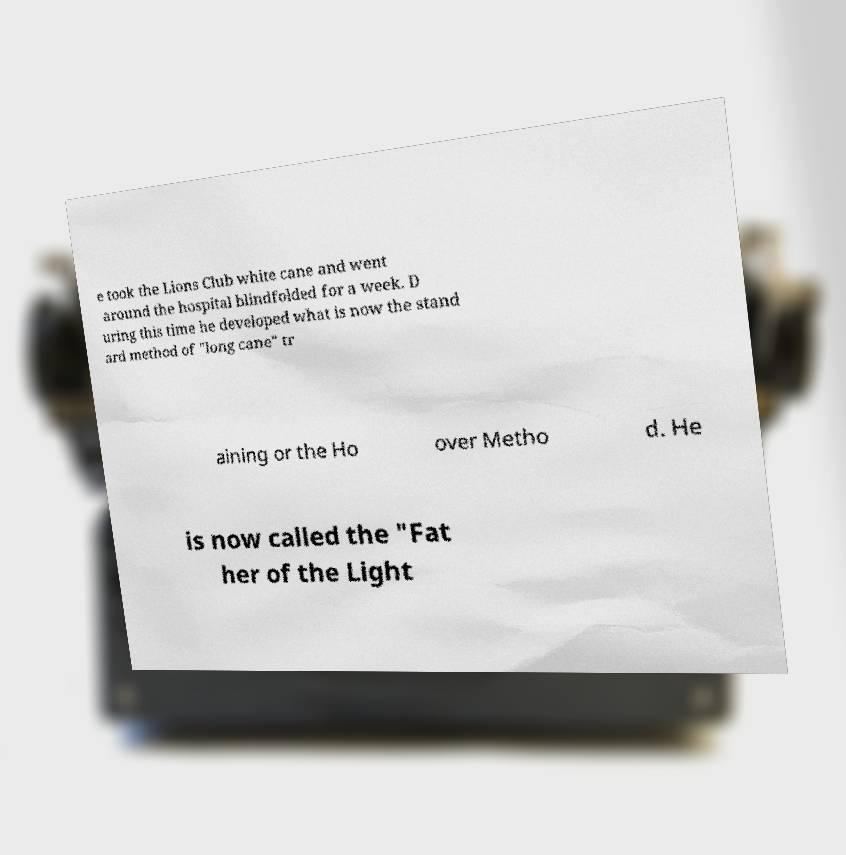Please read and relay the text visible in this image. What does it say? e took the Lions Club white cane and went around the hospital blindfolded for a week. D uring this time he developed what is now the stand ard method of "long cane" tr aining or the Ho over Metho d. He is now called the "Fat her of the Light 